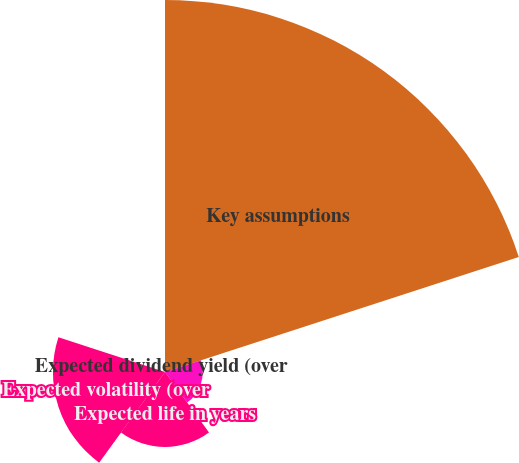<chart> <loc_0><loc_0><loc_500><loc_500><pie_chart><fcel>Key assumptions<fcel>Risk-free interest rate<fcel>Expected life in years<fcel>Expected volatility (over<fcel>Expected dividend yield (over<nl><fcel>62.28%<fcel>6.32%<fcel>12.54%<fcel>18.76%<fcel>0.1%<nl></chart> 